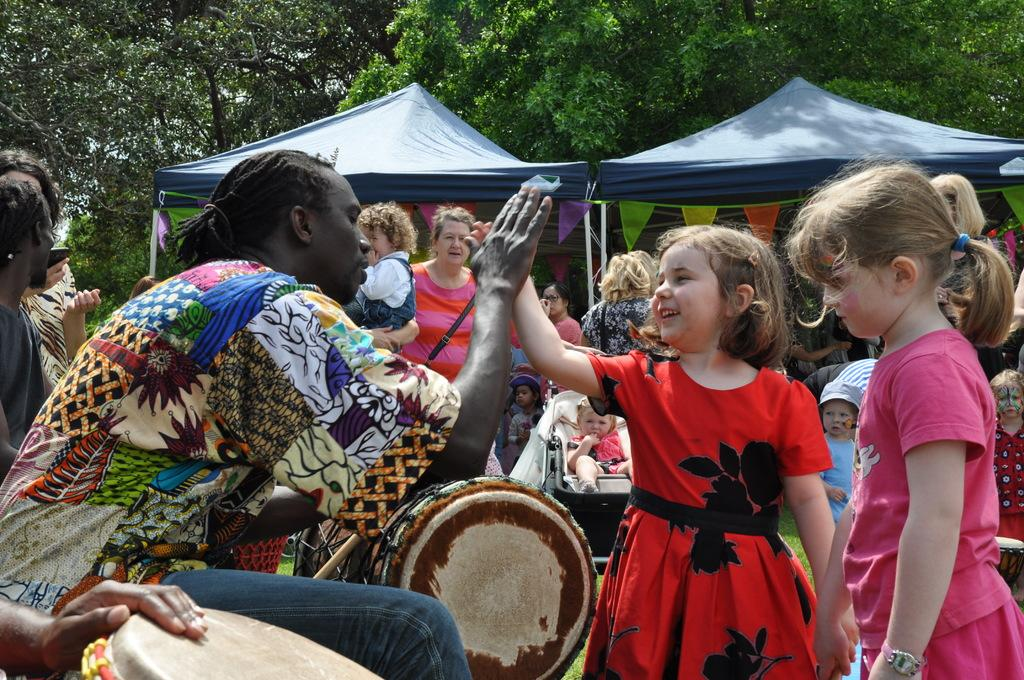How many people are in the image? There are persons in the image, but the exact number is not specified. What is the baby doing in the image? The baby is in a stroller in the image. What type of temporary shelter is visible in the image? There are tents in the image. What can be seen in the background of the image? There are trees visible in the background of the image. What action is the tree performing in the image? There is no tree performing an action in the image; trees are stationary objects. 